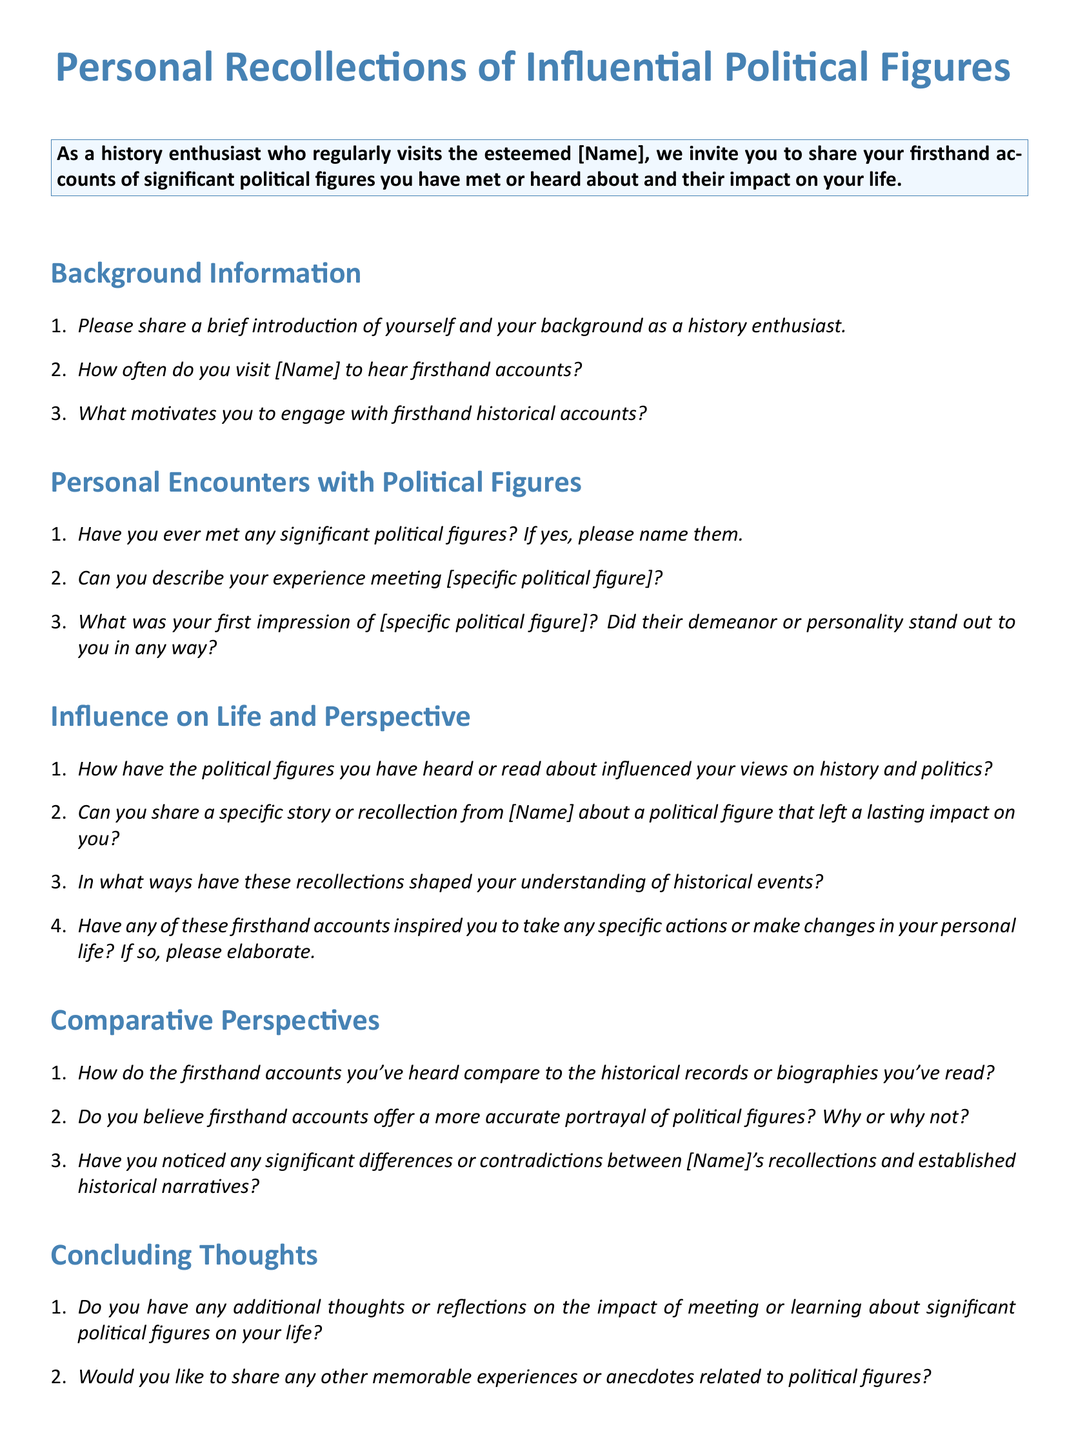What is the title of the survey form? The title is prominently displayed at the top of the document, indicating the survey's focus.
Answer: Personal Recollections of Influential Political Figures Who is the target audience of the survey? The survey is specifically aimed at individuals who share a common interest in history and personal accounts of political figures.
Answer: History enthusiast What type of questions are included in the Background Information section? This section consists of introductory questions that establish the respondent's background and engagement frequency.
Answer: Short-answer questions What is the primary theme of the Personal Encounters with Political Figures section? This section seeks to gather personal experiences and encounters with notable political figures.
Answer: Personal experiences What key themes are addressed in the Influence on Life and Perspective section? This section explores the impact of political figures on personal views, stories, and life changes.
Answer: Impact and recollections What is requested in the concluding thoughts section? Respondents are encouraged to share final reflections and any additional stories related to political figures.
Answer: Additional thoughts or anecdotes Is there a specific political figure mentioned in the sample questions? The questions prompt for personal experiences, but do not specify a name, indicating it can vary by respondent.
Answer: [specific political figure] What type of format is used for the sections and questions in the document? The sections and questions are formatted in a clear, enumerated list style for easy readability.
Answer: Enumerated list Are the survey questions primarily open-ended or closed-ended? The questions in the survey are designed for elaboration and personal reflection, indicating they are open-ended.
Answer: Open-ended 